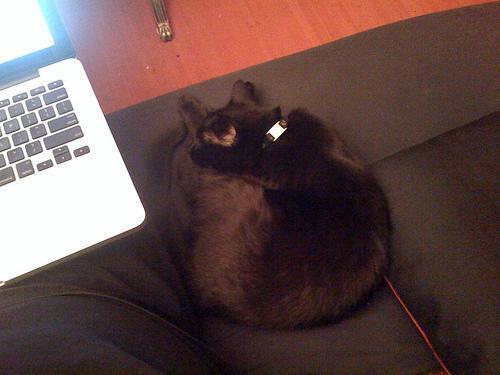How many train tracks?
Give a very brief answer. 0. 